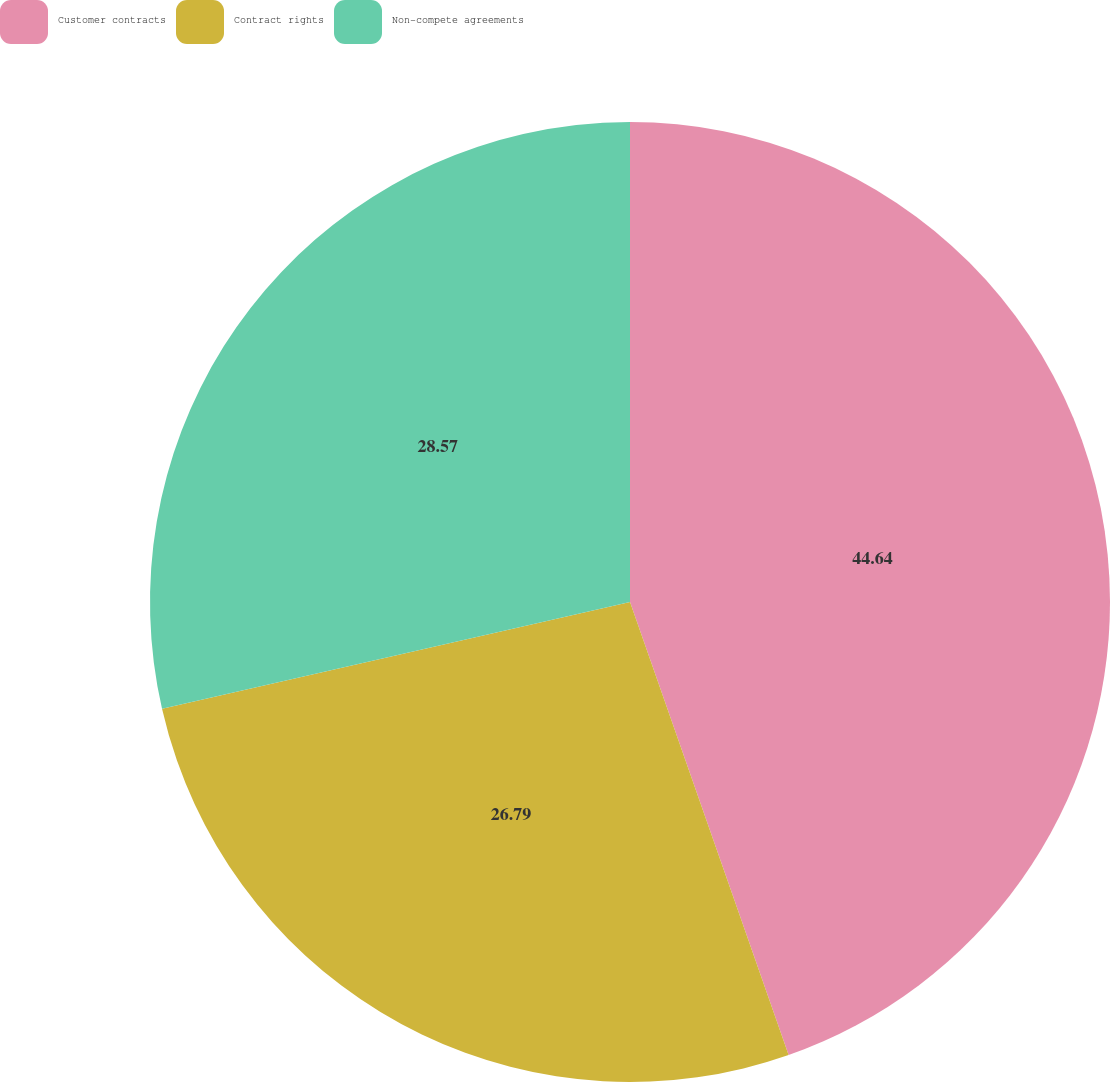Convert chart. <chart><loc_0><loc_0><loc_500><loc_500><pie_chart><fcel>Customer contracts<fcel>Contract rights<fcel>Non-compete agreements<nl><fcel>44.64%<fcel>26.79%<fcel>28.57%<nl></chart> 